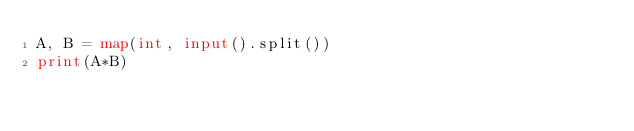Convert code to text. <code><loc_0><loc_0><loc_500><loc_500><_Python_>A, B = map(int, input().split())
print(A*B)
</code> 